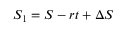<formula> <loc_0><loc_0><loc_500><loc_500>S _ { 1 } = S - r t + \Delta S</formula> 